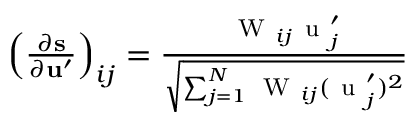Convert formula to latex. <formula><loc_0><loc_0><loc_500><loc_500>\begin{array} { r } { \left ( \frac { \partial s } { \partial u ^ { \prime } } \right ) _ { i j } = \frac { W _ { i j } u _ { j } ^ { \prime } } { \sqrt { \sum _ { j = 1 } ^ { N } W _ { i j } ( u _ { j } ^ { \prime } ) ^ { 2 } } } } \end{array}</formula> 